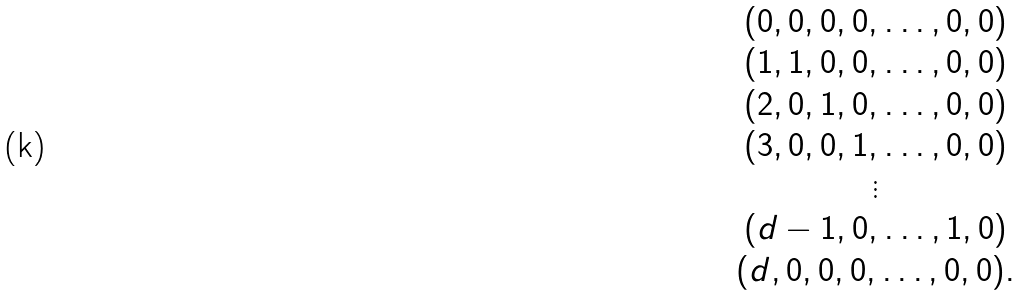<formula> <loc_0><loc_0><loc_500><loc_500>\begin{array} { c } ( 0 , 0 , 0 , 0 , \dots , 0 , 0 ) \\ ( 1 , 1 , 0 , 0 , \dots , 0 , 0 ) \\ ( 2 , 0 , 1 , 0 , \dots , 0 , 0 ) \\ ( 3 , 0 , 0 , 1 , \dots , 0 , 0 ) \\ \vdots \\ ( d - 1 , 0 , \dots , 1 , 0 ) \\ ( d , 0 , 0 , 0 , \dots , 0 , 0 ) . \end{array}</formula> 